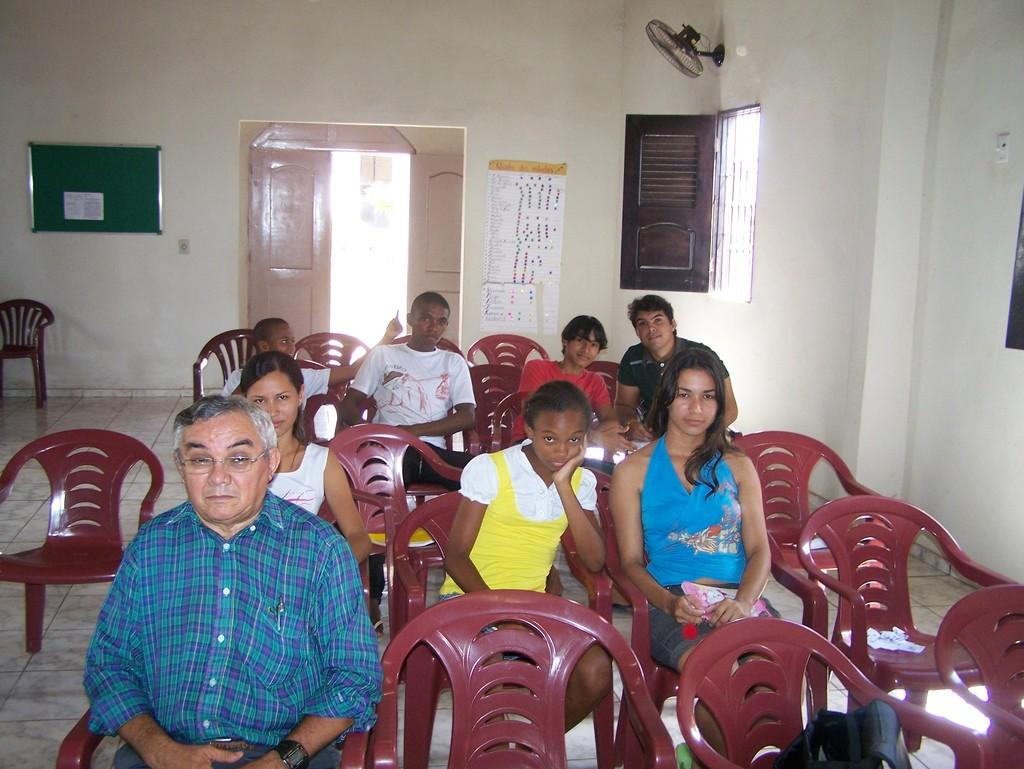Who or what can be seen in the image? There are people in the image. What are the people doing in the image? The people are seated on chairs. Where are the chairs located? The chairs are in a room. What can be found in the room besides the chairs? There is a fan and a notice board in the room. What type of wrench is being used by the people in the image? There is no wrench present in the image; the people are seated on chairs. What kind of juice can be seen being served in the image? There is no juice present in the image; the focus is on the people seated on chairs in a room with a fan and notice board. 